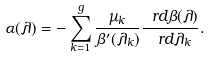<formula> <loc_0><loc_0><loc_500><loc_500>\alpha ( \lambda ) = - \sum _ { k = 1 } ^ { g } \frac { \mu _ { k } } { \beta ^ { \prime } ( \lambda _ { k } ) } \frac { \ r d \beta ( \lambda ) } { \ r d \lambda _ { k } } .</formula> 